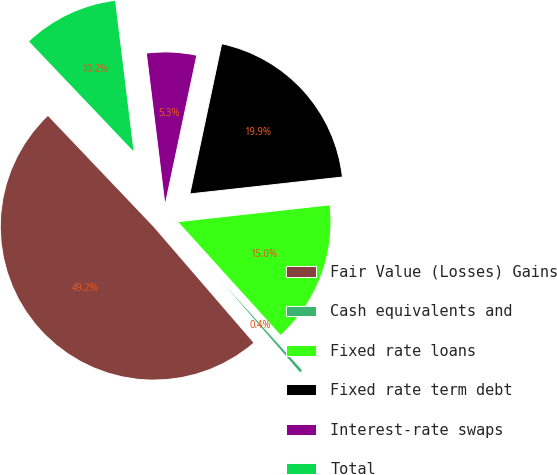<chart> <loc_0><loc_0><loc_500><loc_500><pie_chart><fcel>Fair Value (Losses) Gains<fcel>Cash equivalents and<fcel>Fixed rate loans<fcel>Fixed rate term debt<fcel>Interest-rate swaps<fcel>Total<nl><fcel>49.22%<fcel>0.39%<fcel>15.04%<fcel>19.92%<fcel>5.27%<fcel>10.16%<nl></chart> 